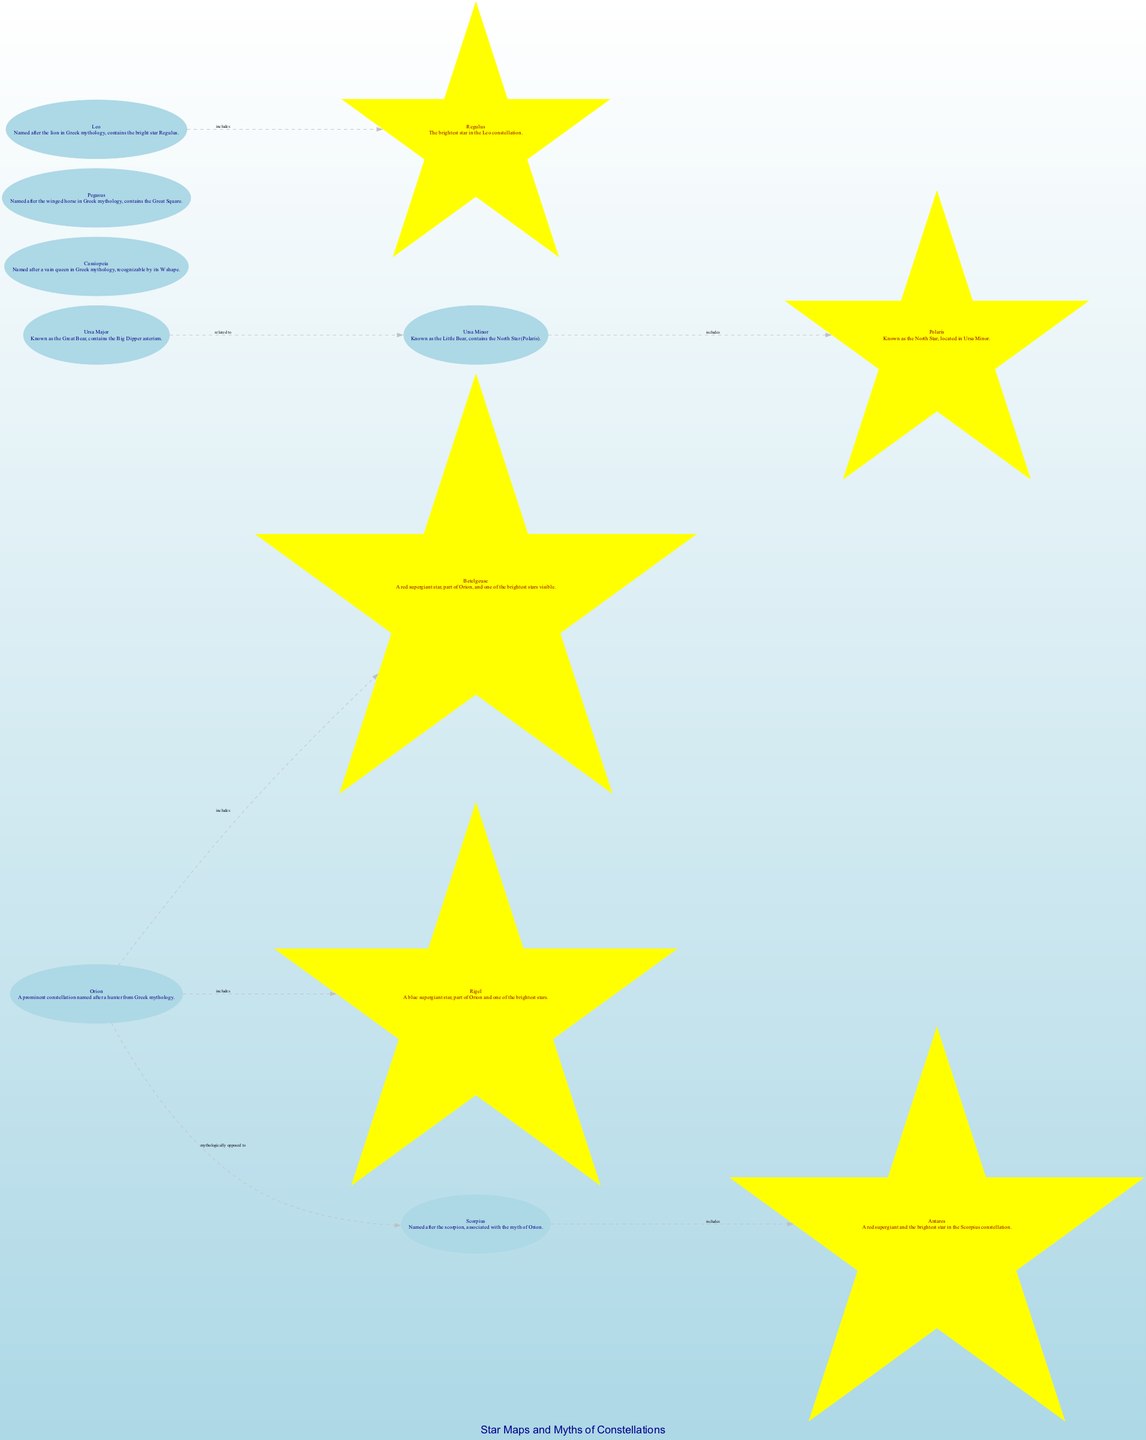What is the name of the brightest star in Orion? According to the diagram, Betelgeuse is mentioned specifically as a bright star that belongs to the Orion constellation, indicating it is the brightest star there.
Answer: Betelgeuse Which constellation is named after a winged horse? The diagram describes the constellation Pegasus as being named after a winged horse in Greek mythology, thus indicating the answer.
Answer: Pegasus How many stars are included in the Orion constellation? The diagram shows two stars, Betelgeuse and Rigel, associated with the Orion constellation, which are indicated as included stars.
Answer: 2 Which two constellations are related to each other in the diagram? The edges show a relationship between Ursa Major and Ursa Minor, demonstrating that these two constellations are related according to the diagram.
Answer: Ursa Major and Ursa Minor What is the brightest star in the Leo constellation? The diagram specifies Regulus as the brightest star within the Leo constellation, providing the direct answer needed.
Answer: Regulus What is the shape that helps identify the Cassiopeia constellation? The diagram highlights that Cassiopeia is recognizable by its W shape, which is a notable feature that can be seen in the star map.
Answer: W shape What star does the Ursa Minor constellation contain? The diagram states that Polaris, known as the North Star, is included in the Ursa Minor constellation, thus answering the question.
Answer: Polaris Which constellation is mythologically described as opposed to Orion? From the diagram, Scorpius is identified as mythologically opposed to Orion, indicating the relationship specified.
Answer: Scorpius Which constellation contains the North Star? The diagram indicates that the Ursa Minor constellation includes Polaris, known as the North Star, which directly answers the question.
Answer: Ursa Minor 